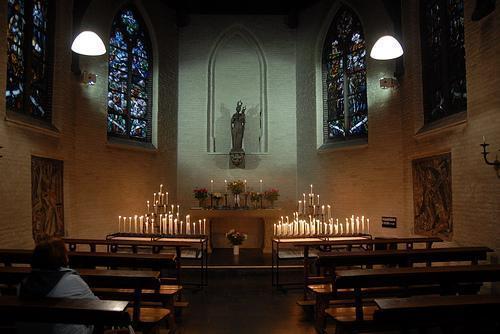How many people are sitting down?
Give a very brief answer. 1. How many lights are turned on in the photo?
Give a very brief answer. 2. How many people are in the pews?
Give a very brief answer. 1. How many benches are in the picture?
Give a very brief answer. 6. 